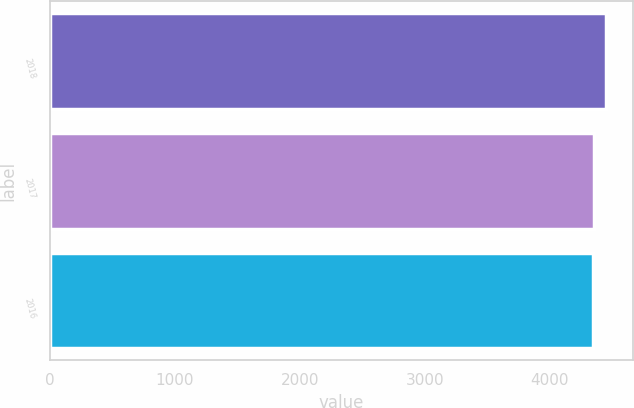<chart> <loc_0><loc_0><loc_500><loc_500><bar_chart><fcel>2018<fcel>2017<fcel>2016<nl><fcel>4447<fcel>4357<fcel>4347<nl></chart> 